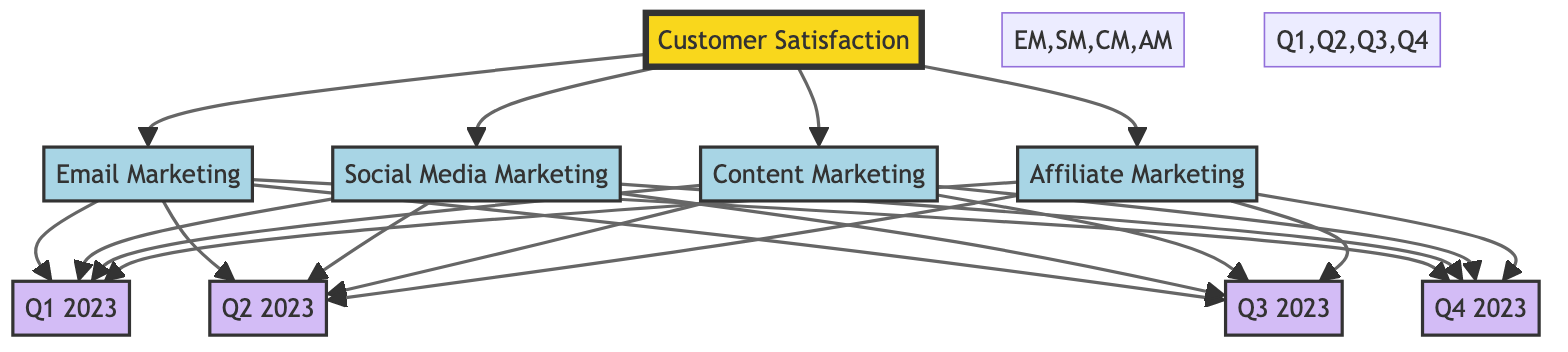What are the main marketing channels depicted in the diagram? The diagram shows four main marketing channels: Email Marketing, Social Media Marketing, Content Marketing, and Affiliate Marketing. These are the primary channels connecting to the Customer Satisfaction node.
Answer: Email Marketing, Social Media Marketing, Content Marketing, Affiliate Marketing Which quarter has the Customer Satisfaction rating for Email Marketing? Email Marketing is connected to all four quarters (Q1, Q2, Q3, Q4), indicating that customer satisfaction ratings can be found for each of these time periods in relation to email marketing efforts.
Answer: All four quarters How many marketing channels are represented in the diagram? There are four marketing channels in the diagram, which connect to the Customer Satisfaction node. This count includes Email Marketing, Social Media Marketing, Content Marketing, and Affiliate Marketing.
Answer: Four Which quarter is connected to Content Marketing? Content Marketing is connected to all four quarters (Q1, Q2, Q3, Q4) in the diagram, showing that satisfaction ratings for this channel can be assessed for each of those timeframes.
Answer: All four quarters Which marketing channel does not have a direct connection to any quarter? All marketing channels listed in the diagram are connected to each quarter (Q1, Q2, Q3, Q4). Therefore, there are no marketing channels that lack a direct connection to a specific quarter.
Answer: None What type of diagram is this specifically? This is an Astronomy Diagram, which illustrates the relationships and connections between different nodes (in this case, relationship between customer satisfaction and marketing channels over time).
Answer: Astronomy Diagram 